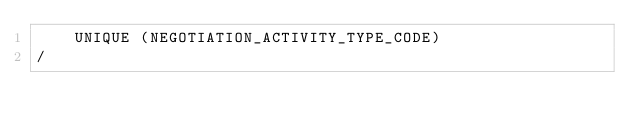Convert code to text. <code><loc_0><loc_0><loc_500><loc_500><_SQL_>	UNIQUE (NEGOTIATION_ACTIVITY_TYPE_CODE)
/
</code> 